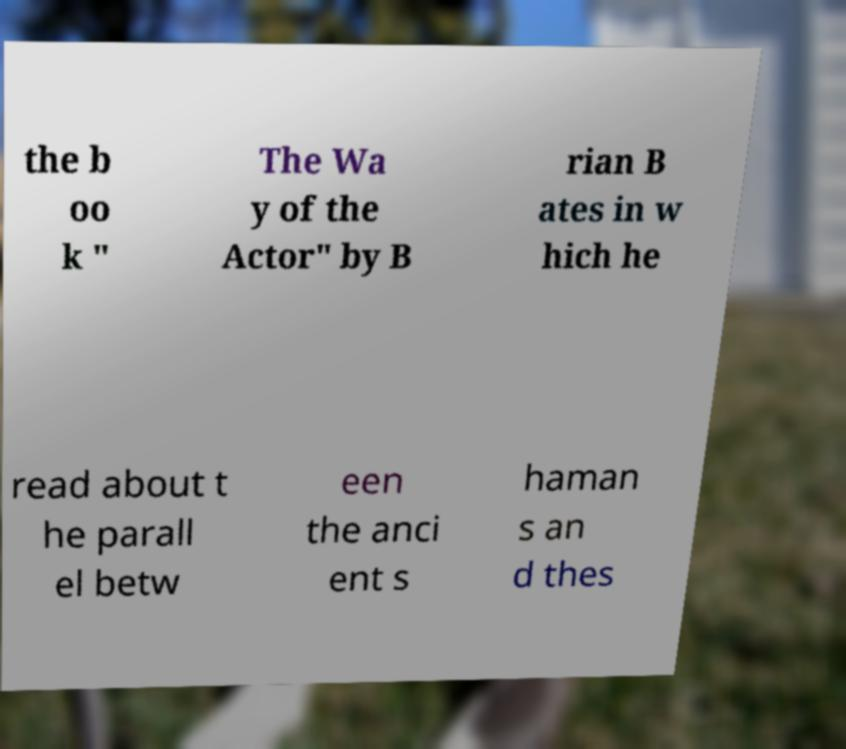For documentation purposes, I need the text within this image transcribed. Could you provide that? the b oo k " The Wa y of the Actor" by B rian B ates in w hich he read about t he parall el betw een the anci ent s haman s an d thes 